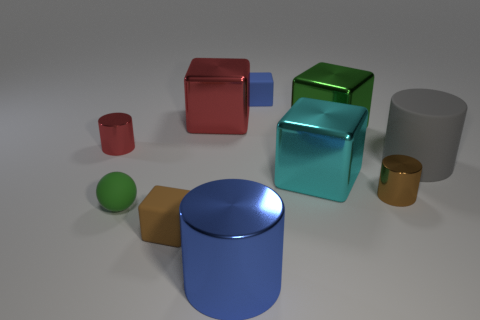Subtract all small blue rubber blocks. How many blocks are left? 4 Subtract 5 cubes. How many cubes are left? 0 Subtract all purple balls. How many green cylinders are left? 0 Subtract all yellow matte things. Subtract all tiny blue things. How many objects are left? 9 Add 6 big cyan blocks. How many big cyan blocks are left? 7 Add 2 small blue rubber cubes. How many small blue rubber cubes exist? 3 Subtract all gray cylinders. How many cylinders are left? 3 Subtract 0 gray blocks. How many objects are left? 10 Subtract all balls. How many objects are left? 9 Subtract all blue balls. Subtract all red cylinders. How many balls are left? 1 